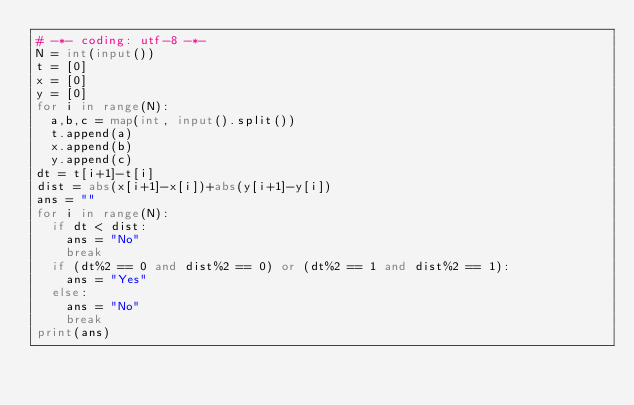Convert code to text. <code><loc_0><loc_0><loc_500><loc_500><_Python_># -*- coding: utf-8 -*-
N = int(input())
t = [0]
x = [0]
y = [0]
for i in range(N):
  a,b,c = map(int, input().split())
  t.append(a)
  x.append(b)
  y.append(c)
dt = t[i+1]-t[i]
dist = abs(x[i+1]-x[i])+abs(y[i+1]-y[i])
ans = ""
for i in range(N):
  if dt < dist:
    ans = "No"
    break
  if (dt%2 == 0 and dist%2 == 0) or (dt%2 == 1 and dist%2 == 1):
    ans = "Yes"
  else:
    ans = "No"
    break
print(ans)</code> 